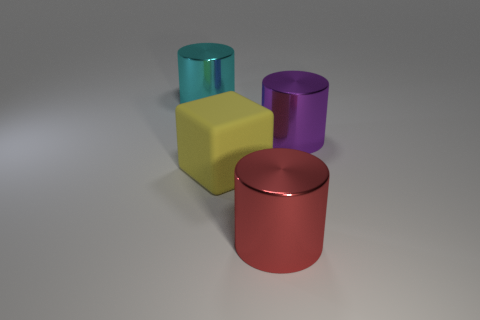The big metallic thing right of the metallic thing in front of the rubber object is what color?
Provide a succinct answer. Purple. There is a big matte thing; does it have the same color as the large object that is in front of the cube?
Offer a terse response. No. What material is the big cylinder that is both on the left side of the big purple metallic thing and behind the yellow rubber cube?
Your answer should be very brief. Metal. Is there a cyan thing of the same size as the purple shiny thing?
Your answer should be compact. Yes. There is a cyan cylinder that is the same size as the yellow rubber block; what material is it?
Keep it short and to the point. Metal. There is a large cyan metallic cylinder; what number of big cubes are left of it?
Your answer should be compact. 0. There is a large metal thing on the right side of the red cylinder; is it the same shape as the yellow matte object?
Offer a terse response. No. Is there a big yellow thing of the same shape as the cyan metal thing?
Make the answer very short. No. What shape is the big metal object on the left side of the cylinder that is in front of the yellow object?
Make the answer very short. Cylinder. What number of red cylinders are made of the same material as the purple object?
Your answer should be compact. 1. 